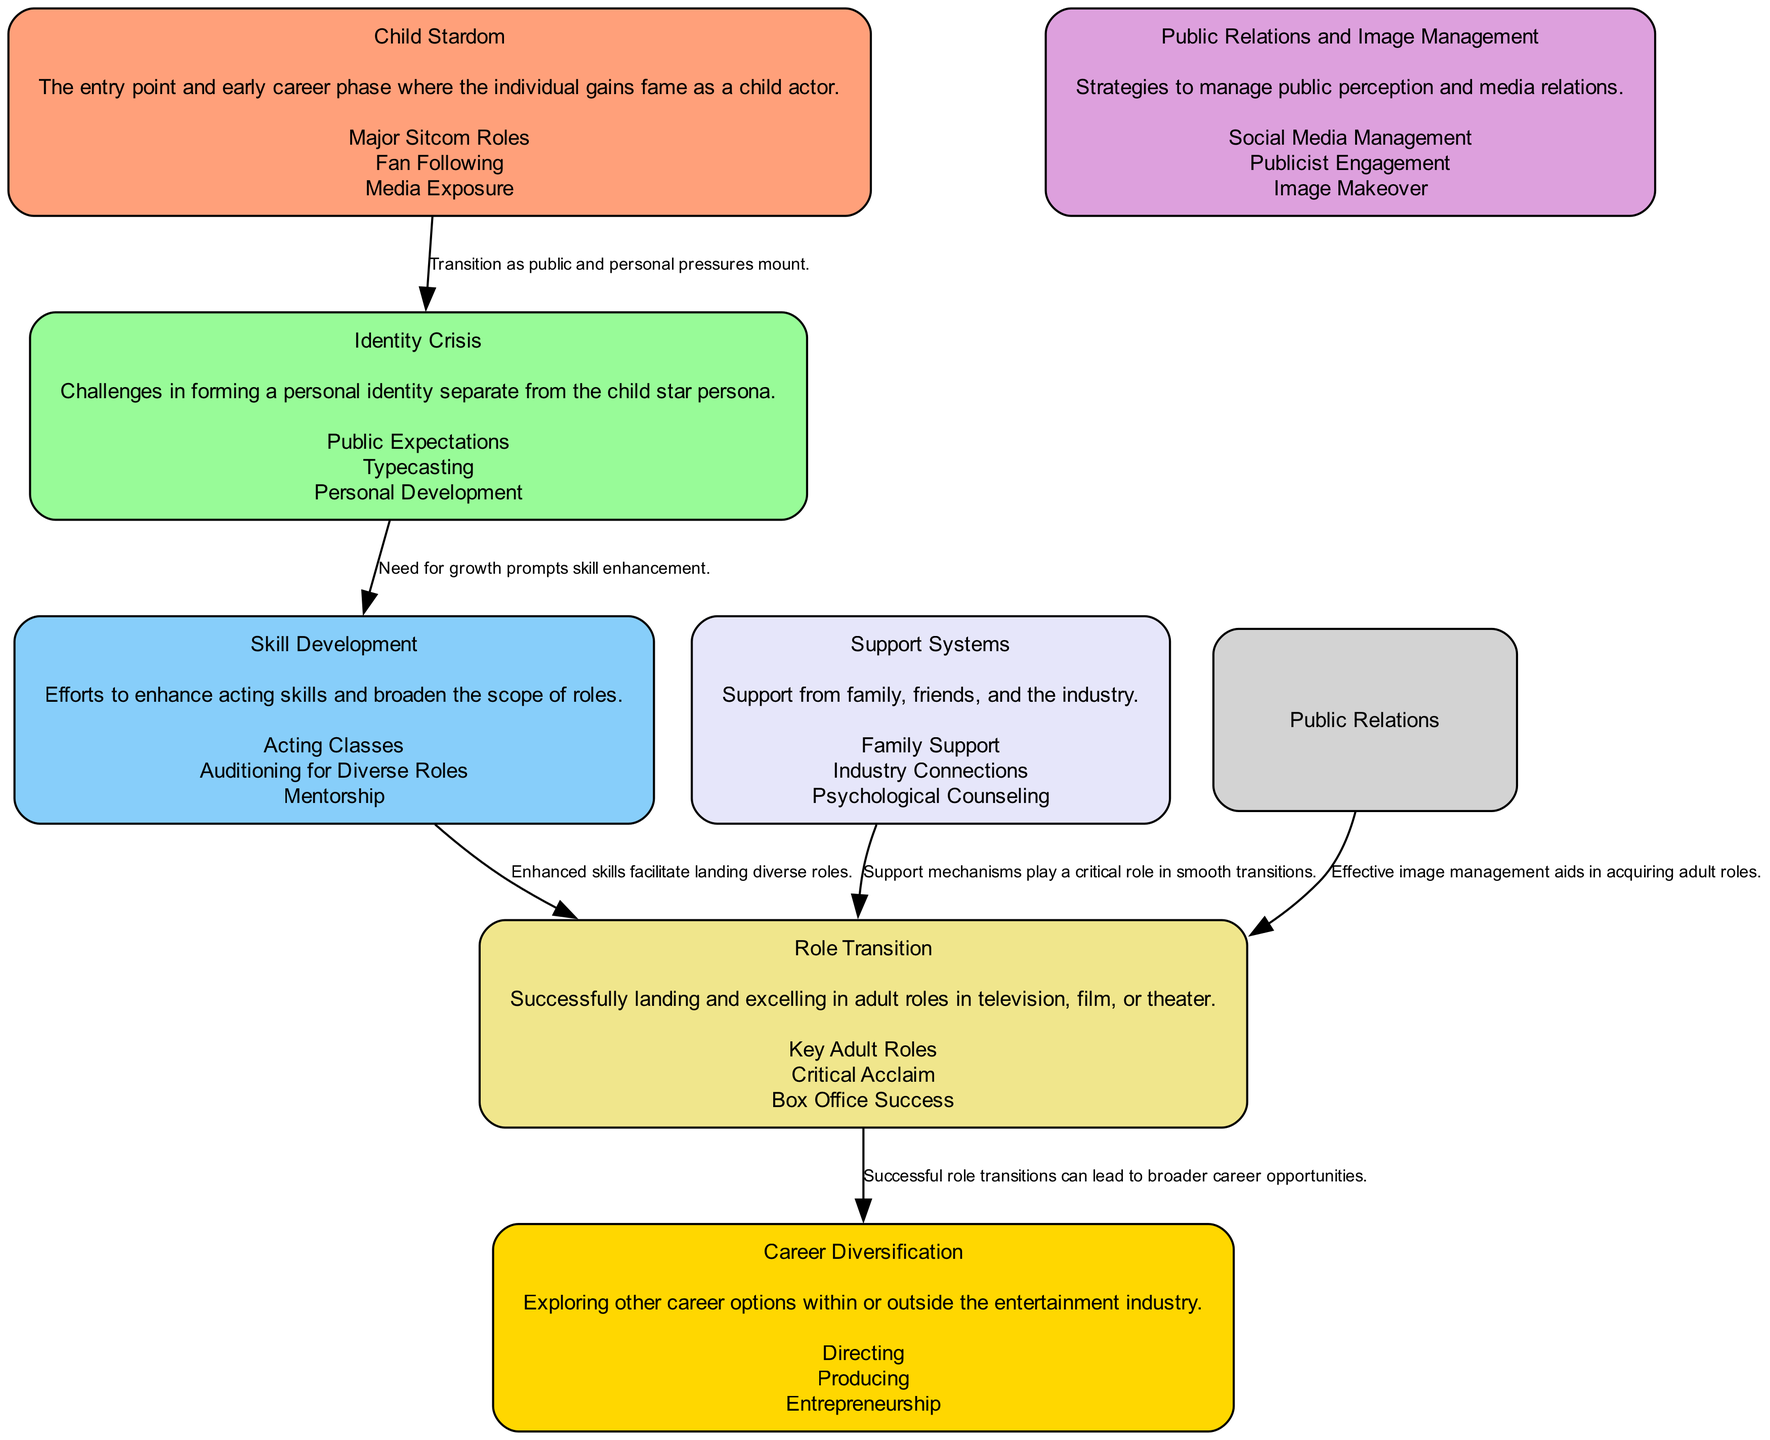What is the first block in the diagram? The first block is labeled "Child Stardom," which is also described as the entry point and early career phase where fame is gained.
Answer: Child Stardom How many blocks are there in total? By counting each labeled section in the diagram, we can identify that there are seven distinct blocks labeled.
Answer: 7 What connects "Identity Crisis" to "Skill Development"? The edge labeled "Need for growth prompts skill enhancement" indicates the connection between these two blocks, showing how identity challenges can lead to a focus on skill enhancement.
Answer: Need for growth prompts skill enhancement Which block describes personal and public pressures? The block titled "Identity Crisis" focuses on the struggles with forming a personal identity and the pressures that arise from public expectations and typecasting.
Answer: Identity Crisis What is a key element of the "Role Transition" block? The block describes three key elements, one of which is "Key Adult Roles," highlighting a significant aspect of successfully transitioning to adult roles in acting.
Answer: Key Adult Roles Which block emphasizes support mechanisms? The "Support Systems" block highlights the importance of having support from family, friends, and the entertainment industry during the transition phase.
Answer: Support Systems How does "Public Relations and Image Management" connect to "Role Transition"? The connection is illustrated by the edge labeled "Effective image management aids in acquiring adult roles," showing how image management strategies influence the transition to adult acting roles.
Answer: Effective image management aids in acquiring adult roles What are two career options noted in "Career Diversification"? The block lists various career options, among which "Directing" and "Producing" are noted as significant pathways for diversification beyond acting.
Answer: Directing, Producing 